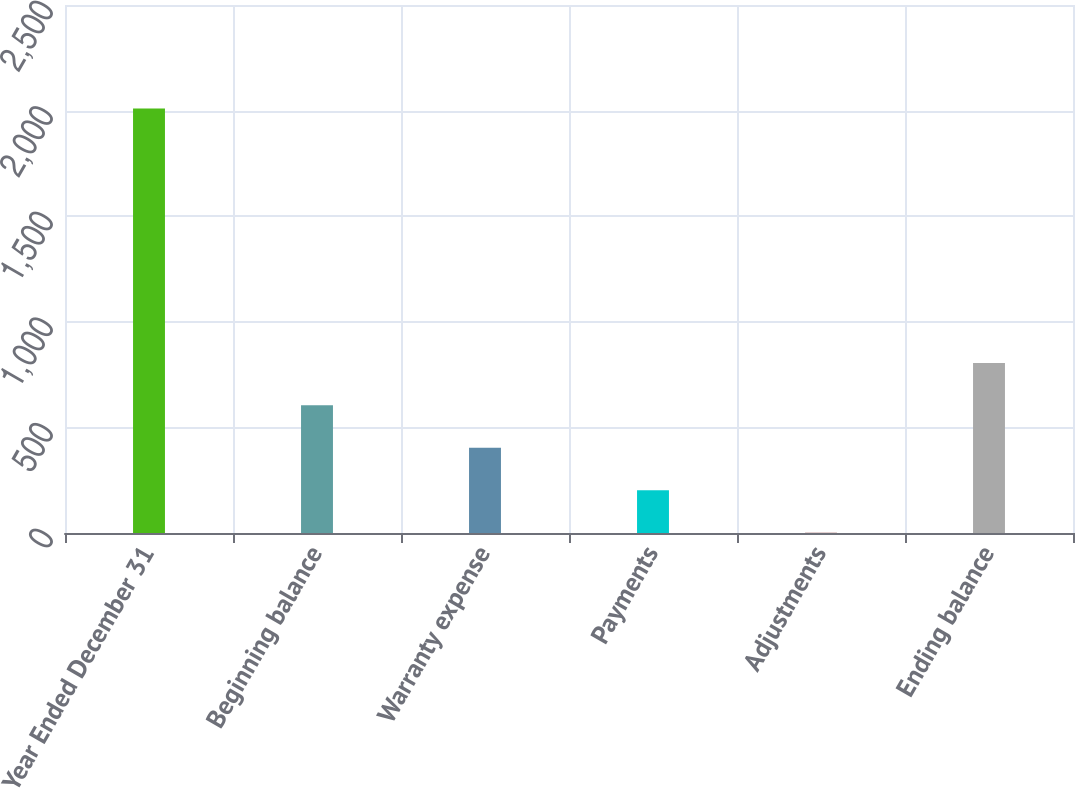<chart> <loc_0><loc_0><loc_500><loc_500><bar_chart><fcel>Year Ended December 31<fcel>Beginning balance<fcel>Warranty expense<fcel>Payments<fcel>Adjustments<fcel>Ending balance<nl><fcel>2010<fcel>604.4<fcel>403.6<fcel>202.8<fcel>2<fcel>805.2<nl></chart> 